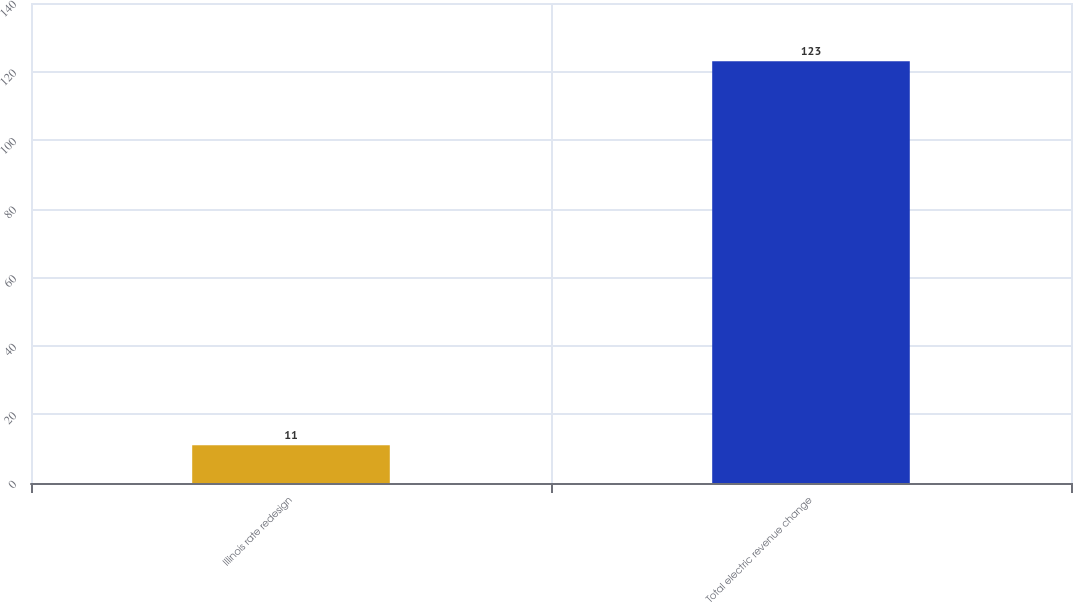Convert chart. <chart><loc_0><loc_0><loc_500><loc_500><bar_chart><fcel>Illinois rate redesign<fcel>Total electric revenue change<nl><fcel>11<fcel>123<nl></chart> 